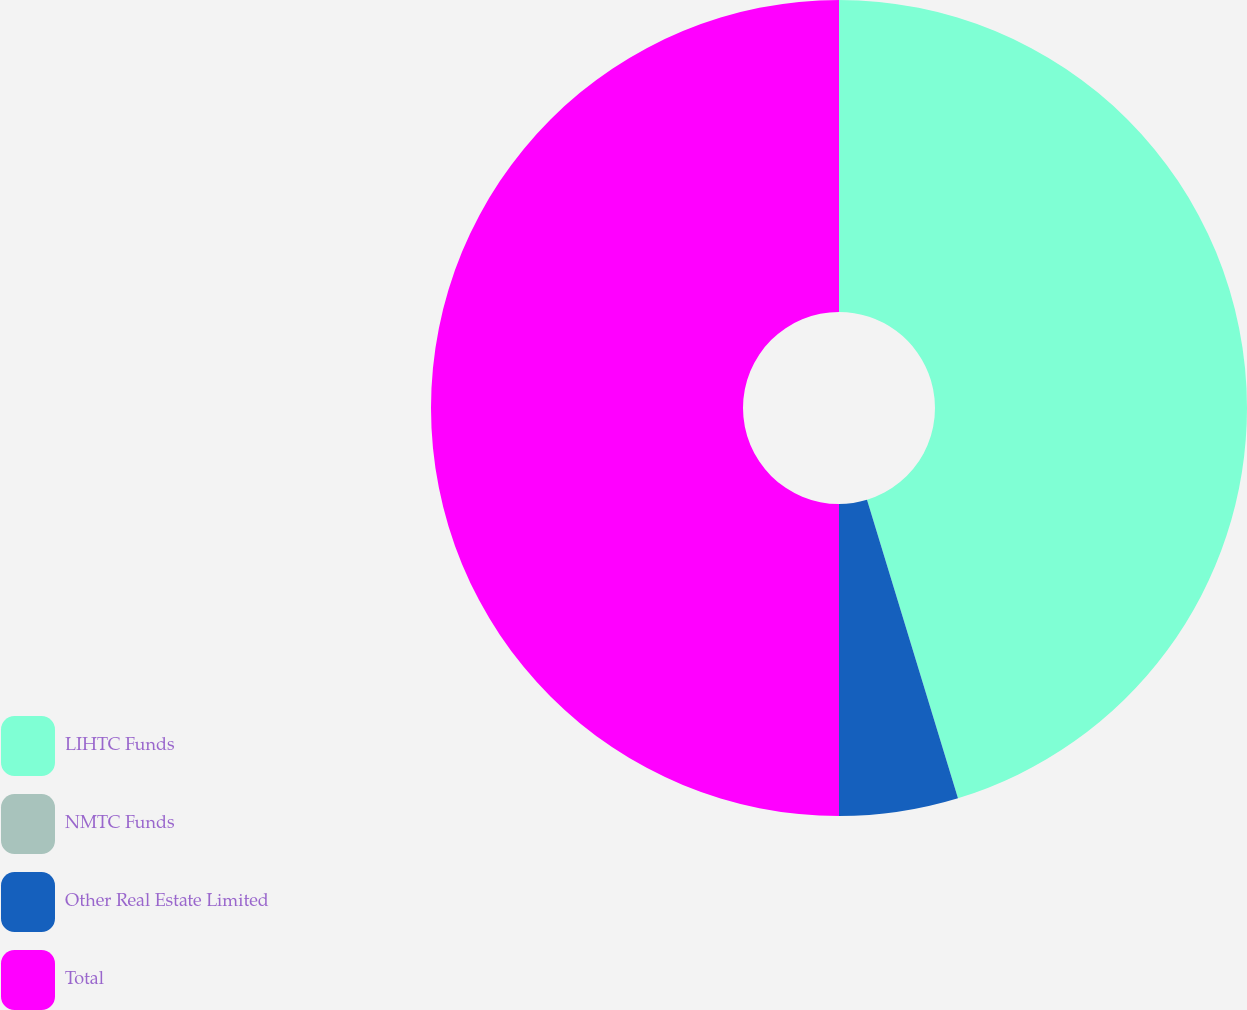Convert chart to OTSL. <chart><loc_0><loc_0><loc_500><loc_500><pie_chart><fcel>LIHTC Funds<fcel>NMTC Funds<fcel>Other Real Estate Limited<fcel>Total<nl><fcel>45.29%<fcel>0.0%<fcel>4.71%<fcel>50.0%<nl></chart> 